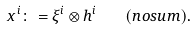<formula> <loc_0><loc_0><loc_500><loc_500>x ^ { i } \colon = \xi ^ { i } \otimes h ^ { i } \quad ( n o s u m ) .</formula> 